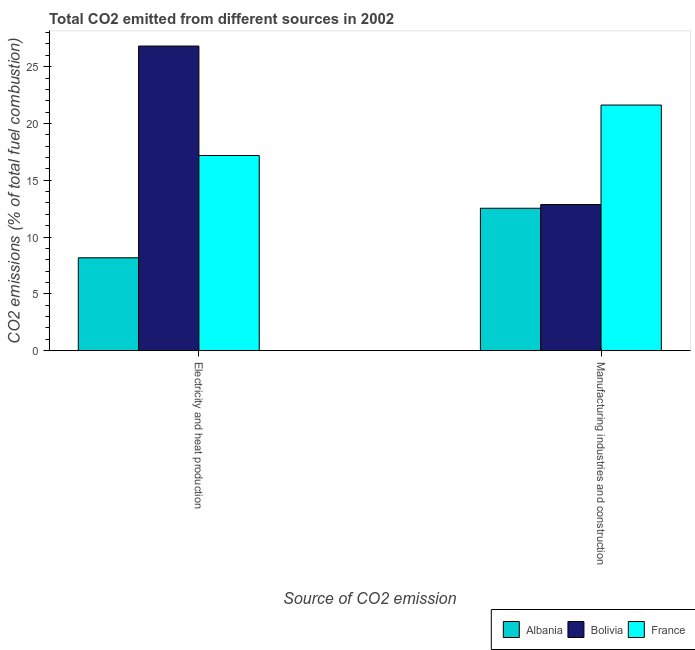Are the number of bars per tick equal to the number of legend labels?
Offer a terse response. Yes. What is the label of the 2nd group of bars from the left?
Give a very brief answer. Manufacturing industries and construction. What is the co2 emissions due to electricity and heat production in Bolivia?
Keep it short and to the point. 26.81. Across all countries, what is the maximum co2 emissions due to electricity and heat production?
Offer a terse response. 26.81. Across all countries, what is the minimum co2 emissions due to manufacturing industries?
Provide a short and direct response. 12.53. In which country was the co2 emissions due to electricity and heat production maximum?
Your response must be concise. Bolivia. In which country was the co2 emissions due to manufacturing industries minimum?
Your response must be concise. Albania. What is the total co2 emissions due to manufacturing industries in the graph?
Ensure brevity in your answer.  47.01. What is the difference between the co2 emissions due to manufacturing industries in Albania and that in Bolivia?
Offer a terse response. -0.33. What is the difference between the co2 emissions due to manufacturing industries in France and the co2 emissions due to electricity and heat production in Bolivia?
Give a very brief answer. -5.19. What is the average co2 emissions due to manufacturing industries per country?
Offer a terse response. 15.67. What is the difference between the co2 emissions due to manufacturing industries and co2 emissions due to electricity and heat production in Albania?
Your answer should be compact. 4.36. What is the ratio of the co2 emissions due to manufacturing industries in Bolivia to that in France?
Provide a short and direct response. 0.59. What does the 2nd bar from the left in Manufacturing industries and construction represents?
Offer a very short reply. Bolivia. What does the 1st bar from the right in Electricity and heat production represents?
Offer a terse response. France. Are all the bars in the graph horizontal?
Offer a terse response. No. What is the difference between two consecutive major ticks on the Y-axis?
Your answer should be compact. 5. Are the values on the major ticks of Y-axis written in scientific E-notation?
Give a very brief answer. No. Where does the legend appear in the graph?
Provide a succinct answer. Bottom right. How many legend labels are there?
Your response must be concise. 3. What is the title of the graph?
Provide a succinct answer. Total CO2 emitted from different sources in 2002. What is the label or title of the X-axis?
Provide a succinct answer. Source of CO2 emission. What is the label or title of the Y-axis?
Offer a very short reply. CO2 emissions (% of total fuel combustion). What is the CO2 emissions (% of total fuel combustion) of Albania in Electricity and heat production?
Offer a very short reply. 8.17. What is the CO2 emissions (% of total fuel combustion) in Bolivia in Electricity and heat production?
Provide a succinct answer. 26.81. What is the CO2 emissions (% of total fuel combustion) of France in Electricity and heat production?
Keep it short and to the point. 17.18. What is the CO2 emissions (% of total fuel combustion) of Albania in Manufacturing industries and construction?
Make the answer very short. 12.53. What is the CO2 emissions (% of total fuel combustion) of Bolivia in Manufacturing industries and construction?
Offer a very short reply. 12.86. What is the CO2 emissions (% of total fuel combustion) of France in Manufacturing industries and construction?
Your answer should be compact. 21.62. Across all Source of CO2 emission, what is the maximum CO2 emissions (% of total fuel combustion) of Albania?
Your answer should be compact. 12.53. Across all Source of CO2 emission, what is the maximum CO2 emissions (% of total fuel combustion) in Bolivia?
Your answer should be compact. 26.81. Across all Source of CO2 emission, what is the maximum CO2 emissions (% of total fuel combustion) in France?
Offer a very short reply. 21.62. Across all Source of CO2 emission, what is the minimum CO2 emissions (% of total fuel combustion) in Albania?
Offer a very short reply. 8.17. Across all Source of CO2 emission, what is the minimum CO2 emissions (% of total fuel combustion) of Bolivia?
Ensure brevity in your answer.  12.86. Across all Source of CO2 emission, what is the minimum CO2 emissions (% of total fuel combustion) of France?
Keep it short and to the point. 17.18. What is the total CO2 emissions (% of total fuel combustion) in Albania in the graph?
Offer a very short reply. 20.71. What is the total CO2 emissions (% of total fuel combustion) in Bolivia in the graph?
Ensure brevity in your answer.  39.67. What is the total CO2 emissions (% of total fuel combustion) in France in the graph?
Keep it short and to the point. 38.8. What is the difference between the CO2 emissions (% of total fuel combustion) of Albania in Electricity and heat production and that in Manufacturing industries and construction?
Keep it short and to the point. -4.36. What is the difference between the CO2 emissions (% of total fuel combustion) in Bolivia in Electricity and heat production and that in Manufacturing industries and construction?
Your answer should be very brief. 13.95. What is the difference between the CO2 emissions (% of total fuel combustion) of France in Electricity and heat production and that in Manufacturing industries and construction?
Provide a short and direct response. -4.44. What is the difference between the CO2 emissions (% of total fuel combustion) in Albania in Electricity and heat production and the CO2 emissions (% of total fuel combustion) in Bolivia in Manufacturing industries and construction?
Offer a terse response. -4.68. What is the difference between the CO2 emissions (% of total fuel combustion) of Albania in Electricity and heat production and the CO2 emissions (% of total fuel combustion) of France in Manufacturing industries and construction?
Keep it short and to the point. -13.44. What is the difference between the CO2 emissions (% of total fuel combustion) of Bolivia in Electricity and heat production and the CO2 emissions (% of total fuel combustion) of France in Manufacturing industries and construction?
Give a very brief answer. 5.19. What is the average CO2 emissions (% of total fuel combustion) of Albania per Source of CO2 emission?
Your answer should be compact. 10.35. What is the average CO2 emissions (% of total fuel combustion) in Bolivia per Source of CO2 emission?
Offer a terse response. 19.84. What is the average CO2 emissions (% of total fuel combustion) in France per Source of CO2 emission?
Ensure brevity in your answer.  19.4. What is the difference between the CO2 emissions (% of total fuel combustion) in Albania and CO2 emissions (% of total fuel combustion) in Bolivia in Electricity and heat production?
Keep it short and to the point. -18.64. What is the difference between the CO2 emissions (% of total fuel combustion) in Albania and CO2 emissions (% of total fuel combustion) in France in Electricity and heat production?
Keep it short and to the point. -9.01. What is the difference between the CO2 emissions (% of total fuel combustion) of Bolivia and CO2 emissions (% of total fuel combustion) of France in Electricity and heat production?
Give a very brief answer. 9.63. What is the difference between the CO2 emissions (% of total fuel combustion) of Albania and CO2 emissions (% of total fuel combustion) of Bolivia in Manufacturing industries and construction?
Give a very brief answer. -0.33. What is the difference between the CO2 emissions (% of total fuel combustion) in Albania and CO2 emissions (% of total fuel combustion) in France in Manufacturing industries and construction?
Provide a short and direct response. -9.08. What is the difference between the CO2 emissions (% of total fuel combustion) in Bolivia and CO2 emissions (% of total fuel combustion) in France in Manufacturing industries and construction?
Make the answer very short. -8.76. What is the ratio of the CO2 emissions (% of total fuel combustion) in Albania in Electricity and heat production to that in Manufacturing industries and construction?
Ensure brevity in your answer.  0.65. What is the ratio of the CO2 emissions (% of total fuel combustion) of Bolivia in Electricity and heat production to that in Manufacturing industries and construction?
Your response must be concise. 2.09. What is the ratio of the CO2 emissions (% of total fuel combustion) in France in Electricity and heat production to that in Manufacturing industries and construction?
Your answer should be very brief. 0.79. What is the difference between the highest and the second highest CO2 emissions (% of total fuel combustion) in Albania?
Ensure brevity in your answer.  4.36. What is the difference between the highest and the second highest CO2 emissions (% of total fuel combustion) in Bolivia?
Ensure brevity in your answer.  13.95. What is the difference between the highest and the second highest CO2 emissions (% of total fuel combustion) in France?
Offer a terse response. 4.44. What is the difference between the highest and the lowest CO2 emissions (% of total fuel combustion) in Albania?
Make the answer very short. 4.36. What is the difference between the highest and the lowest CO2 emissions (% of total fuel combustion) in Bolivia?
Give a very brief answer. 13.95. What is the difference between the highest and the lowest CO2 emissions (% of total fuel combustion) in France?
Offer a very short reply. 4.44. 